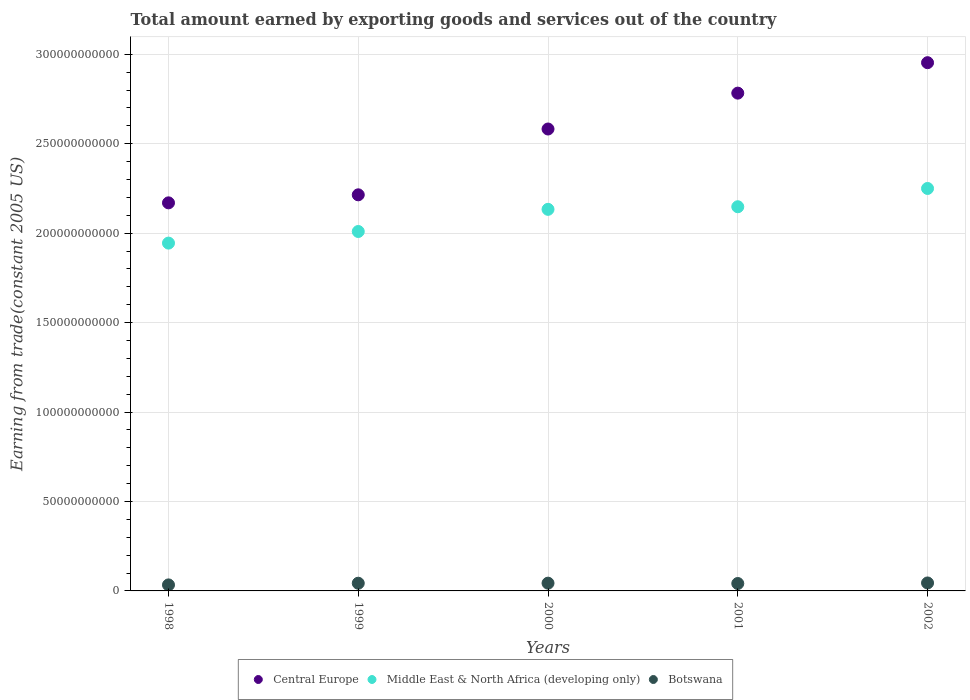Is the number of dotlines equal to the number of legend labels?
Your answer should be compact. Yes. What is the total amount earned by exporting goods and services in Central Europe in 2000?
Provide a succinct answer. 2.58e+11. Across all years, what is the maximum total amount earned by exporting goods and services in Central Europe?
Give a very brief answer. 2.95e+11. Across all years, what is the minimum total amount earned by exporting goods and services in Central Europe?
Your answer should be compact. 2.17e+11. In which year was the total amount earned by exporting goods and services in Botswana maximum?
Provide a succinct answer. 2002. What is the total total amount earned by exporting goods and services in Botswana in the graph?
Your answer should be compact. 2.06e+1. What is the difference between the total amount earned by exporting goods and services in Central Europe in 1998 and that in 2000?
Give a very brief answer. -4.13e+1. What is the difference between the total amount earned by exporting goods and services in Central Europe in 1998 and the total amount earned by exporting goods and services in Botswana in 2002?
Your answer should be compact. 2.13e+11. What is the average total amount earned by exporting goods and services in Middle East & North Africa (developing only) per year?
Keep it short and to the point. 2.10e+11. In the year 1999, what is the difference between the total amount earned by exporting goods and services in Middle East & North Africa (developing only) and total amount earned by exporting goods and services in Botswana?
Make the answer very short. 1.97e+11. In how many years, is the total amount earned by exporting goods and services in Botswana greater than 200000000000 US$?
Ensure brevity in your answer.  0. What is the ratio of the total amount earned by exporting goods and services in Middle East & North Africa (developing only) in 2000 to that in 2002?
Provide a short and direct response. 0.95. Is the difference between the total amount earned by exporting goods and services in Middle East & North Africa (developing only) in 1998 and 2001 greater than the difference between the total amount earned by exporting goods and services in Botswana in 1998 and 2001?
Give a very brief answer. No. What is the difference between the highest and the second highest total amount earned by exporting goods and services in Central Europe?
Your response must be concise. 1.70e+1. What is the difference between the highest and the lowest total amount earned by exporting goods and services in Middle East & North Africa (developing only)?
Provide a short and direct response. 3.05e+1. In how many years, is the total amount earned by exporting goods and services in Botswana greater than the average total amount earned by exporting goods and services in Botswana taken over all years?
Give a very brief answer. 4. Is it the case that in every year, the sum of the total amount earned by exporting goods and services in Central Europe and total amount earned by exporting goods and services in Botswana  is greater than the total amount earned by exporting goods and services in Middle East & North Africa (developing only)?
Offer a terse response. Yes. Is the total amount earned by exporting goods and services in Middle East & North Africa (developing only) strictly greater than the total amount earned by exporting goods and services in Botswana over the years?
Your answer should be compact. Yes. How many years are there in the graph?
Provide a succinct answer. 5. What is the difference between two consecutive major ticks on the Y-axis?
Your answer should be compact. 5.00e+1. Are the values on the major ticks of Y-axis written in scientific E-notation?
Provide a short and direct response. No. Does the graph contain any zero values?
Your answer should be compact. No. Does the graph contain grids?
Your answer should be compact. Yes. What is the title of the graph?
Offer a very short reply. Total amount earned by exporting goods and services out of the country. Does "Cuba" appear as one of the legend labels in the graph?
Make the answer very short. No. What is the label or title of the X-axis?
Provide a succinct answer. Years. What is the label or title of the Y-axis?
Keep it short and to the point. Earning from trade(constant 2005 US). What is the Earning from trade(constant 2005 US) of Central Europe in 1998?
Your response must be concise. 2.17e+11. What is the Earning from trade(constant 2005 US) in Middle East & North Africa (developing only) in 1998?
Offer a terse response. 1.94e+11. What is the Earning from trade(constant 2005 US) in Botswana in 1998?
Make the answer very short. 3.37e+09. What is the Earning from trade(constant 2005 US) in Central Europe in 1999?
Keep it short and to the point. 2.21e+11. What is the Earning from trade(constant 2005 US) of Middle East & North Africa (developing only) in 1999?
Your answer should be compact. 2.01e+11. What is the Earning from trade(constant 2005 US) of Botswana in 1999?
Your answer should be very brief. 4.30e+09. What is the Earning from trade(constant 2005 US) in Central Europe in 2000?
Provide a short and direct response. 2.58e+11. What is the Earning from trade(constant 2005 US) in Middle East & North Africa (developing only) in 2000?
Ensure brevity in your answer.  2.13e+11. What is the Earning from trade(constant 2005 US) of Botswana in 2000?
Your response must be concise. 4.34e+09. What is the Earning from trade(constant 2005 US) of Central Europe in 2001?
Make the answer very short. 2.78e+11. What is the Earning from trade(constant 2005 US) in Middle East & North Africa (developing only) in 2001?
Ensure brevity in your answer.  2.15e+11. What is the Earning from trade(constant 2005 US) in Botswana in 2001?
Offer a very short reply. 4.15e+09. What is the Earning from trade(constant 2005 US) of Central Europe in 2002?
Your answer should be compact. 2.95e+11. What is the Earning from trade(constant 2005 US) of Middle East & North Africa (developing only) in 2002?
Your response must be concise. 2.25e+11. What is the Earning from trade(constant 2005 US) of Botswana in 2002?
Provide a short and direct response. 4.45e+09. Across all years, what is the maximum Earning from trade(constant 2005 US) of Central Europe?
Your response must be concise. 2.95e+11. Across all years, what is the maximum Earning from trade(constant 2005 US) in Middle East & North Africa (developing only)?
Provide a short and direct response. 2.25e+11. Across all years, what is the maximum Earning from trade(constant 2005 US) of Botswana?
Ensure brevity in your answer.  4.45e+09. Across all years, what is the minimum Earning from trade(constant 2005 US) in Central Europe?
Your answer should be very brief. 2.17e+11. Across all years, what is the minimum Earning from trade(constant 2005 US) in Middle East & North Africa (developing only)?
Give a very brief answer. 1.94e+11. Across all years, what is the minimum Earning from trade(constant 2005 US) in Botswana?
Provide a succinct answer. 3.37e+09. What is the total Earning from trade(constant 2005 US) of Central Europe in the graph?
Provide a short and direct response. 1.27e+12. What is the total Earning from trade(constant 2005 US) of Middle East & North Africa (developing only) in the graph?
Provide a short and direct response. 1.05e+12. What is the total Earning from trade(constant 2005 US) in Botswana in the graph?
Your answer should be very brief. 2.06e+1. What is the difference between the Earning from trade(constant 2005 US) in Central Europe in 1998 and that in 1999?
Offer a terse response. -4.49e+09. What is the difference between the Earning from trade(constant 2005 US) in Middle East & North Africa (developing only) in 1998 and that in 1999?
Ensure brevity in your answer.  -6.49e+09. What is the difference between the Earning from trade(constant 2005 US) in Botswana in 1998 and that in 1999?
Provide a short and direct response. -9.32e+08. What is the difference between the Earning from trade(constant 2005 US) in Central Europe in 1998 and that in 2000?
Make the answer very short. -4.13e+1. What is the difference between the Earning from trade(constant 2005 US) of Middle East & North Africa (developing only) in 1998 and that in 2000?
Your answer should be very brief. -1.89e+1. What is the difference between the Earning from trade(constant 2005 US) of Botswana in 1998 and that in 2000?
Offer a very short reply. -9.66e+08. What is the difference between the Earning from trade(constant 2005 US) of Central Europe in 1998 and that in 2001?
Your answer should be compact. -6.13e+1. What is the difference between the Earning from trade(constant 2005 US) in Middle East & North Africa (developing only) in 1998 and that in 2001?
Your response must be concise. -2.03e+1. What is the difference between the Earning from trade(constant 2005 US) of Botswana in 1998 and that in 2001?
Offer a terse response. -7.78e+08. What is the difference between the Earning from trade(constant 2005 US) of Central Europe in 1998 and that in 2002?
Keep it short and to the point. -7.84e+1. What is the difference between the Earning from trade(constant 2005 US) in Middle East & North Africa (developing only) in 1998 and that in 2002?
Give a very brief answer. -3.05e+1. What is the difference between the Earning from trade(constant 2005 US) in Botswana in 1998 and that in 2002?
Provide a succinct answer. -1.08e+09. What is the difference between the Earning from trade(constant 2005 US) of Central Europe in 1999 and that in 2000?
Ensure brevity in your answer.  -3.68e+1. What is the difference between the Earning from trade(constant 2005 US) of Middle East & North Africa (developing only) in 1999 and that in 2000?
Provide a succinct answer. -1.24e+1. What is the difference between the Earning from trade(constant 2005 US) in Botswana in 1999 and that in 2000?
Offer a very short reply. -3.46e+07. What is the difference between the Earning from trade(constant 2005 US) in Central Europe in 1999 and that in 2001?
Ensure brevity in your answer.  -5.69e+1. What is the difference between the Earning from trade(constant 2005 US) in Middle East & North Africa (developing only) in 1999 and that in 2001?
Your response must be concise. -1.38e+1. What is the difference between the Earning from trade(constant 2005 US) of Botswana in 1999 and that in 2001?
Keep it short and to the point. 1.54e+08. What is the difference between the Earning from trade(constant 2005 US) of Central Europe in 1999 and that in 2002?
Give a very brief answer. -7.39e+1. What is the difference between the Earning from trade(constant 2005 US) in Middle East & North Africa (developing only) in 1999 and that in 2002?
Provide a succinct answer. -2.41e+1. What is the difference between the Earning from trade(constant 2005 US) of Botswana in 1999 and that in 2002?
Keep it short and to the point. -1.51e+08. What is the difference between the Earning from trade(constant 2005 US) of Central Europe in 2000 and that in 2001?
Your response must be concise. -2.01e+1. What is the difference between the Earning from trade(constant 2005 US) in Middle East & North Africa (developing only) in 2000 and that in 2001?
Offer a terse response. -1.45e+09. What is the difference between the Earning from trade(constant 2005 US) in Botswana in 2000 and that in 2001?
Keep it short and to the point. 1.88e+08. What is the difference between the Earning from trade(constant 2005 US) of Central Europe in 2000 and that in 2002?
Ensure brevity in your answer.  -3.71e+1. What is the difference between the Earning from trade(constant 2005 US) of Middle East & North Africa (developing only) in 2000 and that in 2002?
Provide a short and direct response. -1.17e+1. What is the difference between the Earning from trade(constant 2005 US) in Botswana in 2000 and that in 2002?
Your answer should be compact. -1.16e+08. What is the difference between the Earning from trade(constant 2005 US) of Central Europe in 2001 and that in 2002?
Your answer should be very brief. -1.70e+1. What is the difference between the Earning from trade(constant 2005 US) of Middle East & North Africa (developing only) in 2001 and that in 2002?
Give a very brief answer. -1.02e+1. What is the difference between the Earning from trade(constant 2005 US) in Botswana in 2001 and that in 2002?
Keep it short and to the point. -3.05e+08. What is the difference between the Earning from trade(constant 2005 US) in Central Europe in 1998 and the Earning from trade(constant 2005 US) in Middle East & North Africa (developing only) in 1999?
Offer a terse response. 1.60e+1. What is the difference between the Earning from trade(constant 2005 US) in Central Europe in 1998 and the Earning from trade(constant 2005 US) in Botswana in 1999?
Offer a terse response. 2.13e+11. What is the difference between the Earning from trade(constant 2005 US) in Middle East & North Africa (developing only) in 1998 and the Earning from trade(constant 2005 US) in Botswana in 1999?
Make the answer very short. 1.90e+11. What is the difference between the Earning from trade(constant 2005 US) in Central Europe in 1998 and the Earning from trade(constant 2005 US) in Middle East & North Africa (developing only) in 2000?
Your answer should be compact. 3.63e+09. What is the difference between the Earning from trade(constant 2005 US) in Central Europe in 1998 and the Earning from trade(constant 2005 US) in Botswana in 2000?
Provide a succinct answer. 2.13e+11. What is the difference between the Earning from trade(constant 2005 US) of Middle East & North Africa (developing only) in 1998 and the Earning from trade(constant 2005 US) of Botswana in 2000?
Offer a very short reply. 1.90e+11. What is the difference between the Earning from trade(constant 2005 US) of Central Europe in 1998 and the Earning from trade(constant 2005 US) of Middle East & North Africa (developing only) in 2001?
Provide a short and direct response. 2.18e+09. What is the difference between the Earning from trade(constant 2005 US) of Central Europe in 1998 and the Earning from trade(constant 2005 US) of Botswana in 2001?
Provide a short and direct response. 2.13e+11. What is the difference between the Earning from trade(constant 2005 US) in Middle East & North Africa (developing only) in 1998 and the Earning from trade(constant 2005 US) in Botswana in 2001?
Your answer should be very brief. 1.90e+11. What is the difference between the Earning from trade(constant 2005 US) in Central Europe in 1998 and the Earning from trade(constant 2005 US) in Middle East & North Africa (developing only) in 2002?
Ensure brevity in your answer.  -8.04e+09. What is the difference between the Earning from trade(constant 2005 US) in Central Europe in 1998 and the Earning from trade(constant 2005 US) in Botswana in 2002?
Ensure brevity in your answer.  2.13e+11. What is the difference between the Earning from trade(constant 2005 US) in Middle East & North Africa (developing only) in 1998 and the Earning from trade(constant 2005 US) in Botswana in 2002?
Your response must be concise. 1.90e+11. What is the difference between the Earning from trade(constant 2005 US) in Central Europe in 1999 and the Earning from trade(constant 2005 US) in Middle East & North Africa (developing only) in 2000?
Make the answer very short. 8.12e+09. What is the difference between the Earning from trade(constant 2005 US) in Central Europe in 1999 and the Earning from trade(constant 2005 US) in Botswana in 2000?
Your response must be concise. 2.17e+11. What is the difference between the Earning from trade(constant 2005 US) in Middle East & North Africa (developing only) in 1999 and the Earning from trade(constant 2005 US) in Botswana in 2000?
Your answer should be compact. 1.97e+11. What is the difference between the Earning from trade(constant 2005 US) of Central Europe in 1999 and the Earning from trade(constant 2005 US) of Middle East & North Africa (developing only) in 2001?
Your response must be concise. 6.67e+09. What is the difference between the Earning from trade(constant 2005 US) in Central Europe in 1999 and the Earning from trade(constant 2005 US) in Botswana in 2001?
Give a very brief answer. 2.17e+11. What is the difference between the Earning from trade(constant 2005 US) in Middle East & North Africa (developing only) in 1999 and the Earning from trade(constant 2005 US) in Botswana in 2001?
Give a very brief answer. 1.97e+11. What is the difference between the Earning from trade(constant 2005 US) of Central Europe in 1999 and the Earning from trade(constant 2005 US) of Middle East & North Africa (developing only) in 2002?
Make the answer very short. -3.56e+09. What is the difference between the Earning from trade(constant 2005 US) in Central Europe in 1999 and the Earning from trade(constant 2005 US) in Botswana in 2002?
Offer a very short reply. 2.17e+11. What is the difference between the Earning from trade(constant 2005 US) of Middle East & North Africa (developing only) in 1999 and the Earning from trade(constant 2005 US) of Botswana in 2002?
Keep it short and to the point. 1.96e+11. What is the difference between the Earning from trade(constant 2005 US) of Central Europe in 2000 and the Earning from trade(constant 2005 US) of Middle East & North Africa (developing only) in 2001?
Provide a short and direct response. 4.35e+1. What is the difference between the Earning from trade(constant 2005 US) of Central Europe in 2000 and the Earning from trade(constant 2005 US) of Botswana in 2001?
Keep it short and to the point. 2.54e+11. What is the difference between the Earning from trade(constant 2005 US) in Middle East & North Africa (developing only) in 2000 and the Earning from trade(constant 2005 US) in Botswana in 2001?
Provide a succinct answer. 2.09e+11. What is the difference between the Earning from trade(constant 2005 US) of Central Europe in 2000 and the Earning from trade(constant 2005 US) of Middle East & North Africa (developing only) in 2002?
Give a very brief answer. 3.32e+1. What is the difference between the Earning from trade(constant 2005 US) of Central Europe in 2000 and the Earning from trade(constant 2005 US) of Botswana in 2002?
Offer a terse response. 2.54e+11. What is the difference between the Earning from trade(constant 2005 US) in Middle East & North Africa (developing only) in 2000 and the Earning from trade(constant 2005 US) in Botswana in 2002?
Offer a very short reply. 2.09e+11. What is the difference between the Earning from trade(constant 2005 US) in Central Europe in 2001 and the Earning from trade(constant 2005 US) in Middle East & North Africa (developing only) in 2002?
Your response must be concise. 5.33e+1. What is the difference between the Earning from trade(constant 2005 US) of Central Europe in 2001 and the Earning from trade(constant 2005 US) of Botswana in 2002?
Provide a succinct answer. 2.74e+11. What is the difference between the Earning from trade(constant 2005 US) of Middle East & North Africa (developing only) in 2001 and the Earning from trade(constant 2005 US) of Botswana in 2002?
Provide a succinct answer. 2.10e+11. What is the average Earning from trade(constant 2005 US) in Central Europe per year?
Provide a succinct answer. 2.54e+11. What is the average Earning from trade(constant 2005 US) of Middle East & North Africa (developing only) per year?
Make the answer very short. 2.10e+11. What is the average Earning from trade(constant 2005 US) of Botswana per year?
Ensure brevity in your answer.  4.12e+09. In the year 1998, what is the difference between the Earning from trade(constant 2005 US) of Central Europe and Earning from trade(constant 2005 US) of Middle East & North Africa (developing only)?
Provide a short and direct response. 2.25e+1. In the year 1998, what is the difference between the Earning from trade(constant 2005 US) in Central Europe and Earning from trade(constant 2005 US) in Botswana?
Offer a terse response. 2.14e+11. In the year 1998, what is the difference between the Earning from trade(constant 2005 US) of Middle East & North Africa (developing only) and Earning from trade(constant 2005 US) of Botswana?
Provide a short and direct response. 1.91e+11. In the year 1999, what is the difference between the Earning from trade(constant 2005 US) in Central Europe and Earning from trade(constant 2005 US) in Middle East & North Africa (developing only)?
Provide a succinct answer. 2.05e+1. In the year 1999, what is the difference between the Earning from trade(constant 2005 US) of Central Europe and Earning from trade(constant 2005 US) of Botswana?
Offer a terse response. 2.17e+11. In the year 1999, what is the difference between the Earning from trade(constant 2005 US) of Middle East & North Africa (developing only) and Earning from trade(constant 2005 US) of Botswana?
Ensure brevity in your answer.  1.97e+11. In the year 2000, what is the difference between the Earning from trade(constant 2005 US) of Central Europe and Earning from trade(constant 2005 US) of Middle East & North Africa (developing only)?
Ensure brevity in your answer.  4.49e+1. In the year 2000, what is the difference between the Earning from trade(constant 2005 US) in Central Europe and Earning from trade(constant 2005 US) in Botswana?
Provide a succinct answer. 2.54e+11. In the year 2000, what is the difference between the Earning from trade(constant 2005 US) in Middle East & North Africa (developing only) and Earning from trade(constant 2005 US) in Botswana?
Offer a very short reply. 2.09e+11. In the year 2001, what is the difference between the Earning from trade(constant 2005 US) of Central Europe and Earning from trade(constant 2005 US) of Middle East & North Africa (developing only)?
Make the answer very short. 6.35e+1. In the year 2001, what is the difference between the Earning from trade(constant 2005 US) in Central Europe and Earning from trade(constant 2005 US) in Botswana?
Provide a succinct answer. 2.74e+11. In the year 2001, what is the difference between the Earning from trade(constant 2005 US) of Middle East & North Africa (developing only) and Earning from trade(constant 2005 US) of Botswana?
Your answer should be very brief. 2.11e+11. In the year 2002, what is the difference between the Earning from trade(constant 2005 US) in Central Europe and Earning from trade(constant 2005 US) in Middle East & North Africa (developing only)?
Your answer should be compact. 7.03e+1. In the year 2002, what is the difference between the Earning from trade(constant 2005 US) of Central Europe and Earning from trade(constant 2005 US) of Botswana?
Keep it short and to the point. 2.91e+11. In the year 2002, what is the difference between the Earning from trade(constant 2005 US) in Middle East & North Africa (developing only) and Earning from trade(constant 2005 US) in Botswana?
Your response must be concise. 2.21e+11. What is the ratio of the Earning from trade(constant 2005 US) in Central Europe in 1998 to that in 1999?
Make the answer very short. 0.98. What is the ratio of the Earning from trade(constant 2005 US) in Middle East & North Africa (developing only) in 1998 to that in 1999?
Provide a short and direct response. 0.97. What is the ratio of the Earning from trade(constant 2005 US) in Botswana in 1998 to that in 1999?
Keep it short and to the point. 0.78. What is the ratio of the Earning from trade(constant 2005 US) of Central Europe in 1998 to that in 2000?
Offer a very short reply. 0.84. What is the ratio of the Earning from trade(constant 2005 US) in Middle East & North Africa (developing only) in 1998 to that in 2000?
Ensure brevity in your answer.  0.91. What is the ratio of the Earning from trade(constant 2005 US) of Botswana in 1998 to that in 2000?
Your answer should be very brief. 0.78. What is the ratio of the Earning from trade(constant 2005 US) in Central Europe in 1998 to that in 2001?
Offer a very short reply. 0.78. What is the ratio of the Earning from trade(constant 2005 US) in Middle East & North Africa (developing only) in 1998 to that in 2001?
Offer a terse response. 0.91. What is the ratio of the Earning from trade(constant 2005 US) in Botswana in 1998 to that in 2001?
Your response must be concise. 0.81. What is the ratio of the Earning from trade(constant 2005 US) of Central Europe in 1998 to that in 2002?
Your answer should be compact. 0.73. What is the ratio of the Earning from trade(constant 2005 US) in Middle East & North Africa (developing only) in 1998 to that in 2002?
Offer a very short reply. 0.86. What is the ratio of the Earning from trade(constant 2005 US) in Botswana in 1998 to that in 2002?
Provide a succinct answer. 0.76. What is the ratio of the Earning from trade(constant 2005 US) of Central Europe in 1999 to that in 2000?
Your response must be concise. 0.86. What is the ratio of the Earning from trade(constant 2005 US) in Middle East & North Africa (developing only) in 1999 to that in 2000?
Keep it short and to the point. 0.94. What is the ratio of the Earning from trade(constant 2005 US) of Botswana in 1999 to that in 2000?
Provide a succinct answer. 0.99. What is the ratio of the Earning from trade(constant 2005 US) in Central Europe in 1999 to that in 2001?
Keep it short and to the point. 0.8. What is the ratio of the Earning from trade(constant 2005 US) of Middle East & North Africa (developing only) in 1999 to that in 2001?
Ensure brevity in your answer.  0.94. What is the ratio of the Earning from trade(constant 2005 US) of Botswana in 1999 to that in 2001?
Give a very brief answer. 1.04. What is the ratio of the Earning from trade(constant 2005 US) of Central Europe in 1999 to that in 2002?
Provide a succinct answer. 0.75. What is the ratio of the Earning from trade(constant 2005 US) in Middle East & North Africa (developing only) in 1999 to that in 2002?
Give a very brief answer. 0.89. What is the ratio of the Earning from trade(constant 2005 US) in Botswana in 1999 to that in 2002?
Ensure brevity in your answer.  0.97. What is the ratio of the Earning from trade(constant 2005 US) in Central Europe in 2000 to that in 2001?
Offer a very short reply. 0.93. What is the ratio of the Earning from trade(constant 2005 US) in Botswana in 2000 to that in 2001?
Your answer should be compact. 1.05. What is the ratio of the Earning from trade(constant 2005 US) of Central Europe in 2000 to that in 2002?
Keep it short and to the point. 0.87. What is the ratio of the Earning from trade(constant 2005 US) of Middle East & North Africa (developing only) in 2000 to that in 2002?
Provide a succinct answer. 0.95. What is the ratio of the Earning from trade(constant 2005 US) in Botswana in 2000 to that in 2002?
Your response must be concise. 0.97. What is the ratio of the Earning from trade(constant 2005 US) of Central Europe in 2001 to that in 2002?
Your response must be concise. 0.94. What is the ratio of the Earning from trade(constant 2005 US) in Middle East & North Africa (developing only) in 2001 to that in 2002?
Offer a very short reply. 0.95. What is the ratio of the Earning from trade(constant 2005 US) of Botswana in 2001 to that in 2002?
Give a very brief answer. 0.93. What is the difference between the highest and the second highest Earning from trade(constant 2005 US) of Central Europe?
Offer a terse response. 1.70e+1. What is the difference between the highest and the second highest Earning from trade(constant 2005 US) of Middle East & North Africa (developing only)?
Make the answer very short. 1.02e+1. What is the difference between the highest and the second highest Earning from trade(constant 2005 US) in Botswana?
Ensure brevity in your answer.  1.16e+08. What is the difference between the highest and the lowest Earning from trade(constant 2005 US) of Central Europe?
Your response must be concise. 7.84e+1. What is the difference between the highest and the lowest Earning from trade(constant 2005 US) of Middle East & North Africa (developing only)?
Offer a terse response. 3.05e+1. What is the difference between the highest and the lowest Earning from trade(constant 2005 US) in Botswana?
Your answer should be compact. 1.08e+09. 